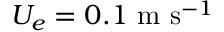Convert formula to latex. <formula><loc_0><loc_0><loc_500><loc_500>U _ { e } = 0 . 1 \ m \ s ^ { - 1 }</formula> 